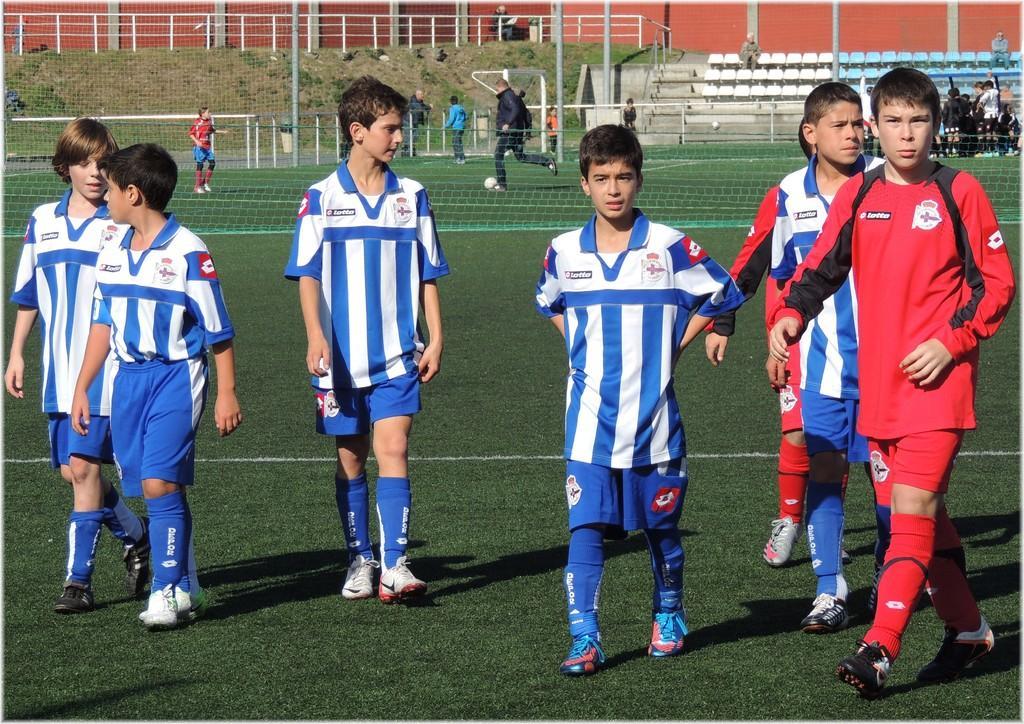Describe this image in one or two sentences. In this image, I can see group of boy walking. I think this is the football ground. I can see sportsnet. Here is the man playing football. I can see group of people standing. These are the poles. I can see two people sitting on the chairs. This is the wall. 